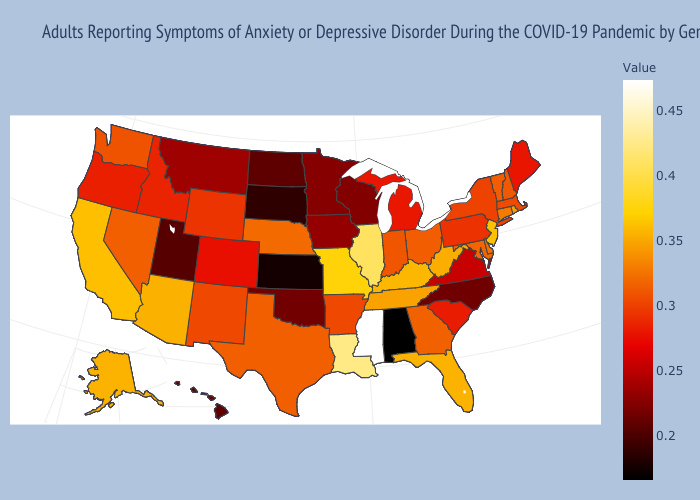Which states hav the highest value in the Northeast?
Quick response, please. New Jersey. Is the legend a continuous bar?
Quick response, please. Yes. Among the states that border North Dakota , which have the highest value?
Write a very short answer. Montana. Does Mississippi have the highest value in the USA?
Keep it brief. Yes. Does Illinois have the highest value in the MidWest?
Be succinct. Yes. 